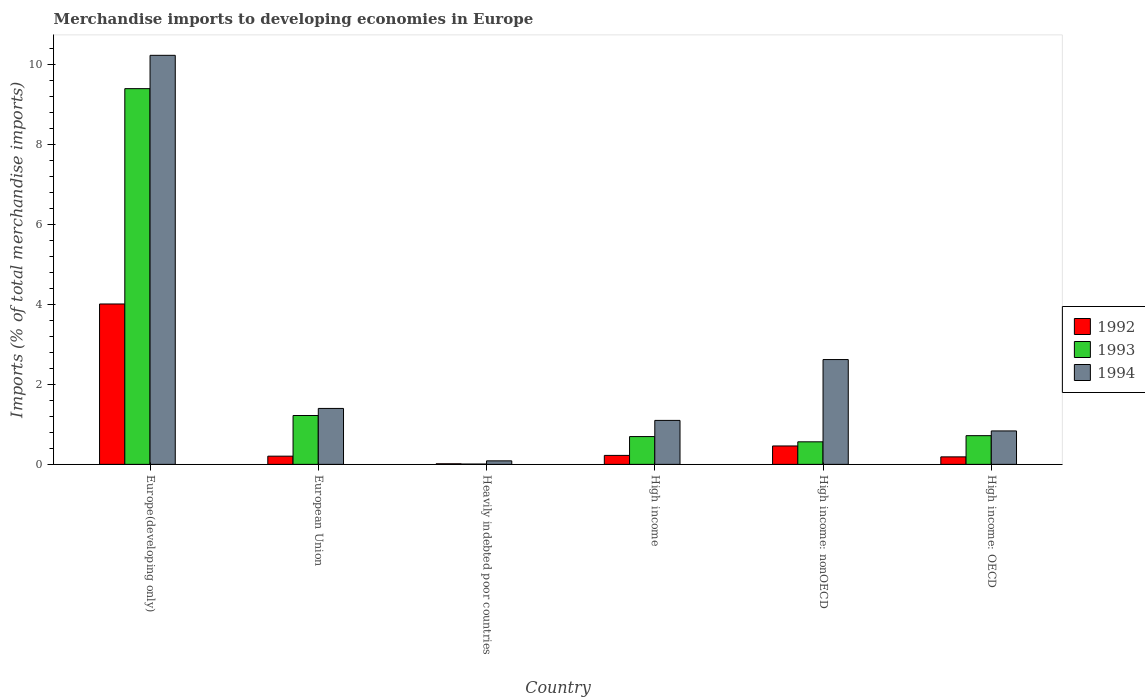Are the number of bars on each tick of the X-axis equal?
Provide a succinct answer. Yes. How many bars are there on the 5th tick from the left?
Provide a succinct answer. 3. How many bars are there on the 4th tick from the right?
Your answer should be compact. 3. What is the label of the 5th group of bars from the left?
Offer a very short reply. High income: nonOECD. In how many cases, is the number of bars for a given country not equal to the number of legend labels?
Your response must be concise. 0. What is the percentage total merchandise imports in 1993 in Europe(developing only)?
Make the answer very short. 9.39. Across all countries, what is the maximum percentage total merchandise imports in 1994?
Provide a short and direct response. 10.23. Across all countries, what is the minimum percentage total merchandise imports in 1993?
Make the answer very short. 0.01. In which country was the percentage total merchandise imports in 1993 maximum?
Provide a short and direct response. Europe(developing only). In which country was the percentage total merchandise imports in 1992 minimum?
Offer a very short reply. Heavily indebted poor countries. What is the total percentage total merchandise imports in 1994 in the graph?
Provide a short and direct response. 16.27. What is the difference between the percentage total merchandise imports in 1992 in European Union and that in High income: nonOECD?
Offer a terse response. -0.25. What is the difference between the percentage total merchandise imports in 1992 in Europe(developing only) and the percentage total merchandise imports in 1993 in Heavily indebted poor countries?
Offer a very short reply. 4. What is the average percentage total merchandise imports in 1993 per country?
Provide a short and direct response. 2.1. What is the difference between the percentage total merchandise imports of/in 1994 and percentage total merchandise imports of/in 1993 in Heavily indebted poor countries?
Provide a short and direct response. 0.08. In how many countries, is the percentage total merchandise imports in 1994 greater than 5.2 %?
Offer a very short reply. 1. What is the ratio of the percentage total merchandise imports in 1992 in Europe(developing only) to that in Heavily indebted poor countries?
Your response must be concise. 265.61. Is the difference between the percentage total merchandise imports in 1994 in European Union and High income: OECD greater than the difference between the percentage total merchandise imports in 1993 in European Union and High income: OECD?
Your answer should be very brief. Yes. What is the difference between the highest and the second highest percentage total merchandise imports in 1993?
Your answer should be compact. -8.68. What is the difference between the highest and the lowest percentage total merchandise imports in 1994?
Your answer should be very brief. 10.14. Is the sum of the percentage total merchandise imports in 1993 in Europe(developing only) and High income: OECD greater than the maximum percentage total merchandise imports in 1994 across all countries?
Offer a very short reply. No. How many bars are there?
Offer a terse response. 18. How many countries are there in the graph?
Offer a very short reply. 6. What is the difference between two consecutive major ticks on the Y-axis?
Make the answer very short. 2. Does the graph contain grids?
Give a very brief answer. No. Where does the legend appear in the graph?
Your response must be concise. Center right. How many legend labels are there?
Offer a terse response. 3. How are the legend labels stacked?
Ensure brevity in your answer.  Vertical. What is the title of the graph?
Your answer should be compact. Merchandise imports to developing economies in Europe. Does "1990" appear as one of the legend labels in the graph?
Provide a short and direct response. No. What is the label or title of the Y-axis?
Your answer should be very brief. Imports (% of total merchandise imports). What is the Imports (% of total merchandise imports) of 1992 in Europe(developing only)?
Offer a terse response. 4.01. What is the Imports (% of total merchandise imports) in 1993 in Europe(developing only)?
Keep it short and to the point. 9.39. What is the Imports (% of total merchandise imports) in 1994 in Europe(developing only)?
Give a very brief answer. 10.23. What is the Imports (% of total merchandise imports) of 1992 in European Union?
Your answer should be very brief. 0.21. What is the Imports (% of total merchandise imports) in 1993 in European Union?
Make the answer very short. 1.22. What is the Imports (% of total merchandise imports) in 1994 in European Union?
Your response must be concise. 1.4. What is the Imports (% of total merchandise imports) of 1992 in Heavily indebted poor countries?
Make the answer very short. 0.02. What is the Imports (% of total merchandise imports) of 1993 in Heavily indebted poor countries?
Offer a very short reply. 0.01. What is the Imports (% of total merchandise imports) of 1994 in Heavily indebted poor countries?
Make the answer very short. 0.09. What is the Imports (% of total merchandise imports) of 1992 in High income?
Give a very brief answer. 0.22. What is the Imports (% of total merchandise imports) in 1993 in High income?
Ensure brevity in your answer.  0.7. What is the Imports (% of total merchandise imports) of 1994 in High income?
Ensure brevity in your answer.  1.1. What is the Imports (% of total merchandise imports) in 1992 in High income: nonOECD?
Provide a succinct answer. 0.46. What is the Imports (% of total merchandise imports) of 1993 in High income: nonOECD?
Provide a succinct answer. 0.56. What is the Imports (% of total merchandise imports) in 1994 in High income: nonOECD?
Provide a succinct answer. 2.62. What is the Imports (% of total merchandise imports) in 1992 in High income: OECD?
Your response must be concise. 0.19. What is the Imports (% of total merchandise imports) in 1993 in High income: OECD?
Your answer should be compact. 0.72. What is the Imports (% of total merchandise imports) of 1994 in High income: OECD?
Offer a very short reply. 0.84. Across all countries, what is the maximum Imports (% of total merchandise imports) in 1992?
Provide a short and direct response. 4.01. Across all countries, what is the maximum Imports (% of total merchandise imports) in 1993?
Make the answer very short. 9.39. Across all countries, what is the maximum Imports (% of total merchandise imports) in 1994?
Offer a terse response. 10.23. Across all countries, what is the minimum Imports (% of total merchandise imports) of 1992?
Provide a short and direct response. 0.02. Across all countries, what is the minimum Imports (% of total merchandise imports) of 1993?
Your answer should be very brief. 0.01. Across all countries, what is the minimum Imports (% of total merchandise imports) in 1994?
Your answer should be compact. 0.09. What is the total Imports (% of total merchandise imports) of 1992 in the graph?
Your answer should be very brief. 5.1. What is the total Imports (% of total merchandise imports) in 1993 in the graph?
Offer a terse response. 12.6. What is the total Imports (% of total merchandise imports) of 1994 in the graph?
Provide a succinct answer. 16.27. What is the difference between the Imports (% of total merchandise imports) of 1992 in Europe(developing only) and that in European Union?
Your answer should be very brief. 3.8. What is the difference between the Imports (% of total merchandise imports) in 1993 in Europe(developing only) and that in European Union?
Give a very brief answer. 8.17. What is the difference between the Imports (% of total merchandise imports) of 1994 in Europe(developing only) and that in European Union?
Your answer should be compact. 8.83. What is the difference between the Imports (% of total merchandise imports) of 1992 in Europe(developing only) and that in Heavily indebted poor countries?
Provide a succinct answer. 4. What is the difference between the Imports (% of total merchandise imports) in 1993 in Europe(developing only) and that in Heavily indebted poor countries?
Give a very brief answer. 9.39. What is the difference between the Imports (% of total merchandise imports) in 1994 in Europe(developing only) and that in Heavily indebted poor countries?
Keep it short and to the point. 10.14. What is the difference between the Imports (% of total merchandise imports) in 1992 in Europe(developing only) and that in High income?
Provide a succinct answer. 3.79. What is the difference between the Imports (% of total merchandise imports) of 1993 in Europe(developing only) and that in High income?
Make the answer very short. 8.7. What is the difference between the Imports (% of total merchandise imports) of 1994 in Europe(developing only) and that in High income?
Give a very brief answer. 9.13. What is the difference between the Imports (% of total merchandise imports) of 1992 in Europe(developing only) and that in High income: nonOECD?
Make the answer very short. 3.55. What is the difference between the Imports (% of total merchandise imports) of 1993 in Europe(developing only) and that in High income: nonOECD?
Provide a short and direct response. 8.83. What is the difference between the Imports (% of total merchandise imports) in 1994 in Europe(developing only) and that in High income: nonOECD?
Your response must be concise. 7.61. What is the difference between the Imports (% of total merchandise imports) in 1992 in Europe(developing only) and that in High income: OECD?
Provide a succinct answer. 3.82. What is the difference between the Imports (% of total merchandise imports) of 1993 in Europe(developing only) and that in High income: OECD?
Offer a terse response. 8.68. What is the difference between the Imports (% of total merchandise imports) of 1994 in Europe(developing only) and that in High income: OECD?
Give a very brief answer. 9.39. What is the difference between the Imports (% of total merchandise imports) in 1992 in European Union and that in Heavily indebted poor countries?
Provide a short and direct response. 0.19. What is the difference between the Imports (% of total merchandise imports) of 1993 in European Union and that in Heavily indebted poor countries?
Your answer should be compact. 1.21. What is the difference between the Imports (% of total merchandise imports) of 1994 in European Union and that in Heavily indebted poor countries?
Provide a short and direct response. 1.31. What is the difference between the Imports (% of total merchandise imports) of 1992 in European Union and that in High income?
Keep it short and to the point. -0.02. What is the difference between the Imports (% of total merchandise imports) of 1993 in European Union and that in High income?
Ensure brevity in your answer.  0.53. What is the difference between the Imports (% of total merchandise imports) of 1994 in European Union and that in High income?
Provide a succinct answer. 0.3. What is the difference between the Imports (% of total merchandise imports) of 1992 in European Union and that in High income: nonOECD?
Offer a terse response. -0.25. What is the difference between the Imports (% of total merchandise imports) in 1993 in European Union and that in High income: nonOECD?
Offer a terse response. 0.66. What is the difference between the Imports (% of total merchandise imports) of 1994 in European Union and that in High income: nonOECD?
Offer a very short reply. -1.22. What is the difference between the Imports (% of total merchandise imports) of 1992 in European Union and that in High income: OECD?
Provide a short and direct response. 0.02. What is the difference between the Imports (% of total merchandise imports) of 1993 in European Union and that in High income: OECD?
Offer a very short reply. 0.5. What is the difference between the Imports (% of total merchandise imports) of 1994 in European Union and that in High income: OECD?
Your response must be concise. 0.56. What is the difference between the Imports (% of total merchandise imports) of 1992 in Heavily indebted poor countries and that in High income?
Provide a short and direct response. -0.21. What is the difference between the Imports (% of total merchandise imports) in 1993 in Heavily indebted poor countries and that in High income?
Ensure brevity in your answer.  -0.69. What is the difference between the Imports (% of total merchandise imports) in 1994 in Heavily indebted poor countries and that in High income?
Provide a succinct answer. -1.01. What is the difference between the Imports (% of total merchandise imports) of 1992 in Heavily indebted poor countries and that in High income: nonOECD?
Ensure brevity in your answer.  -0.45. What is the difference between the Imports (% of total merchandise imports) in 1993 in Heavily indebted poor countries and that in High income: nonOECD?
Your answer should be very brief. -0.56. What is the difference between the Imports (% of total merchandise imports) of 1994 in Heavily indebted poor countries and that in High income: nonOECD?
Make the answer very short. -2.53. What is the difference between the Imports (% of total merchandise imports) of 1992 in Heavily indebted poor countries and that in High income: OECD?
Your answer should be compact. -0.17. What is the difference between the Imports (% of total merchandise imports) of 1993 in Heavily indebted poor countries and that in High income: OECD?
Your response must be concise. -0.71. What is the difference between the Imports (% of total merchandise imports) of 1994 in Heavily indebted poor countries and that in High income: OECD?
Make the answer very short. -0.75. What is the difference between the Imports (% of total merchandise imports) of 1992 in High income and that in High income: nonOECD?
Provide a succinct answer. -0.24. What is the difference between the Imports (% of total merchandise imports) in 1993 in High income and that in High income: nonOECD?
Your response must be concise. 0.13. What is the difference between the Imports (% of total merchandise imports) in 1994 in High income and that in High income: nonOECD?
Your answer should be very brief. -1.52. What is the difference between the Imports (% of total merchandise imports) in 1992 in High income and that in High income: OECD?
Your response must be concise. 0.04. What is the difference between the Imports (% of total merchandise imports) in 1993 in High income and that in High income: OECD?
Provide a succinct answer. -0.02. What is the difference between the Imports (% of total merchandise imports) in 1994 in High income and that in High income: OECD?
Provide a short and direct response. 0.26. What is the difference between the Imports (% of total merchandise imports) of 1992 in High income: nonOECD and that in High income: OECD?
Your response must be concise. 0.27. What is the difference between the Imports (% of total merchandise imports) in 1993 in High income: nonOECD and that in High income: OECD?
Make the answer very short. -0.15. What is the difference between the Imports (% of total merchandise imports) of 1994 in High income: nonOECD and that in High income: OECD?
Make the answer very short. 1.78. What is the difference between the Imports (% of total merchandise imports) of 1992 in Europe(developing only) and the Imports (% of total merchandise imports) of 1993 in European Union?
Your answer should be compact. 2.79. What is the difference between the Imports (% of total merchandise imports) in 1992 in Europe(developing only) and the Imports (% of total merchandise imports) in 1994 in European Union?
Offer a very short reply. 2.61. What is the difference between the Imports (% of total merchandise imports) in 1993 in Europe(developing only) and the Imports (% of total merchandise imports) in 1994 in European Union?
Offer a terse response. 8. What is the difference between the Imports (% of total merchandise imports) of 1992 in Europe(developing only) and the Imports (% of total merchandise imports) of 1993 in Heavily indebted poor countries?
Provide a succinct answer. 4. What is the difference between the Imports (% of total merchandise imports) of 1992 in Europe(developing only) and the Imports (% of total merchandise imports) of 1994 in Heavily indebted poor countries?
Make the answer very short. 3.92. What is the difference between the Imports (% of total merchandise imports) in 1993 in Europe(developing only) and the Imports (% of total merchandise imports) in 1994 in Heavily indebted poor countries?
Keep it short and to the point. 9.31. What is the difference between the Imports (% of total merchandise imports) in 1992 in Europe(developing only) and the Imports (% of total merchandise imports) in 1993 in High income?
Keep it short and to the point. 3.32. What is the difference between the Imports (% of total merchandise imports) of 1992 in Europe(developing only) and the Imports (% of total merchandise imports) of 1994 in High income?
Provide a succinct answer. 2.91. What is the difference between the Imports (% of total merchandise imports) of 1993 in Europe(developing only) and the Imports (% of total merchandise imports) of 1994 in High income?
Your answer should be compact. 8.29. What is the difference between the Imports (% of total merchandise imports) in 1992 in Europe(developing only) and the Imports (% of total merchandise imports) in 1993 in High income: nonOECD?
Ensure brevity in your answer.  3.45. What is the difference between the Imports (% of total merchandise imports) of 1992 in Europe(developing only) and the Imports (% of total merchandise imports) of 1994 in High income: nonOECD?
Your answer should be very brief. 1.39. What is the difference between the Imports (% of total merchandise imports) of 1993 in Europe(developing only) and the Imports (% of total merchandise imports) of 1994 in High income: nonOECD?
Offer a very short reply. 6.77. What is the difference between the Imports (% of total merchandise imports) in 1992 in Europe(developing only) and the Imports (% of total merchandise imports) in 1993 in High income: OECD?
Offer a very short reply. 3.29. What is the difference between the Imports (% of total merchandise imports) in 1992 in Europe(developing only) and the Imports (% of total merchandise imports) in 1994 in High income: OECD?
Provide a succinct answer. 3.17. What is the difference between the Imports (% of total merchandise imports) of 1993 in Europe(developing only) and the Imports (% of total merchandise imports) of 1994 in High income: OECD?
Give a very brief answer. 8.56. What is the difference between the Imports (% of total merchandise imports) of 1992 in European Union and the Imports (% of total merchandise imports) of 1993 in Heavily indebted poor countries?
Provide a short and direct response. 0.2. What is the difference between the Imports (% of total merchandise imports) of 1992 in European Union and the Imports (% of total merchandise imports) of 1994 in Heavily indebted poor countries?
Ensure brevity in your answer.  0.12. What is the difference between the Imports (% of total merchandise imports) of 1993 in European Union and the Imports (% of total merchandise imports) of 1994 in Heavily indebted poor countries?
Your answer should be very brief. 1.13. What is the difference between the Imports (% of total merchandise imports) in 1992 in European Union and the Imports (% of total merchandise imports) in 1993 in High income?
Offer a very short reply. -0.49. What is the difference between the Imports (% of total merchandise imports) of 1992 in European Union and the Imports (% of total merchandise imports) of 1994 in High income?
Make the answer very short. -0.89. What is the difference between the Imports (% of total merchandise imports) in 1993 in European Union and the Imports (% of total merchandise imports) in 1994 in High income?
Your response must be concise. 0.12. What is the difference between the Imports (% of total merchandise imports) of 1992 in European Union and the Imports (% of total merchandise imports) of 1993 in High income: nonOECD?
Offer a very short reply. -0.36. What is the difference between the Imports (% of total merchandise imports) of 1992 in European Union and the Imports (% of total merchandise imports) of 1994 in High income: nonOECD?
Offer a terse response. -2.42. What is the difference between the Imports (% of total merchandise imports) of 1993 in European Union and the Imports (% of total merchandise imports) of 1994 in High income: nonOECD?
Keep it short and to the point. -1.4. What is the difference between the Imports (% of total merchandise imports) in 1992 in European Union and the Imports (% of total merchandise imports) in 1993 in High income: OECD?
Give a very brief answer. -0.51. What is the difference between the Imports (% of total merchandise imports) in 1992 in European Union and the Imports (% of total merchandise imports) in 1994 in High income: OECD?
Your answer should be very brief. -0.63. What is the difference between the Imports (% of total merchandise imports) of 1993 in European Union and the Imports (% of total merchandise imports) of 1994 in High income: OECD?
Give a very brief answer. 0.39. What is the difference between the Imports (% of total merchandise imports) in 1992 in Heavily indebted poor countries and the Imports (% of total merchandise imports) in 1993 in High income?
Your answer should be compact. -0.68. What is the difference between the Imports (% of total merchandise imports) of 1992 in Heavily indebted poor countries and the Imports (% of total merchandise imports) of 1994 in High income?
Your answer should be very brief. -1.08. What is the difference between the Imports (% of total merchandise imports) of 1993 in Heavily indebted poor countries and the Imports (% of total merchandise imports) of 1994 in High income?
Provide a short and direct response. -1.09. What is the difference between the Imports (% of total merchandise imports) in 1992 in Heavily indebted poor countries and the Imports (% of total merchandise imports) in 1993 in High income: nonOECD?
Offer a terse response. -0.55. What is the difference between the Imports (% of total merchandise imports) in 1992 in Heavily indebted poor countries and the Imports (% of total merchandise imports) in 1994 in High income: nonOECD?
Offer a very short reply. -2.61. What is the difference between the Imports (% of total merchandise imports) of 1993 in Heavily indebted poor countries and the Imports (% of total merchandise imports) of 1994 in High income: nonOECD?
Your response must be concise. -2.61. What is the difference between the Imports (% of total merchandise imports) of 1992 in Heavily indebted poor countries and the Imports (% of total merchandise imports) of 1993 in High income: OECD?
Your answer should be compact. -0.7. What is the difference between the Imports (% of total merchandise imports) in 1992 in Heavily indebted poor countries and the Imports (% of total merchandise imports) in 1994 in High income: OECD?
Offer a terse response. -0.82. What is the difference between the Imports (% of total merchandise imports) of 1993 in Heavily indebted poor countries and the Imports (% of total merchandise imports) of 1994 in High income: OECD?
Make the answer very short. -0.83. What is the difference between the Imports (% of total merchandise imports) in 1992 in High income and the Imports (% of total merchandise imports) in 1993 in High income: nonOECD?
Keep it short and to the point. -0.34. What is the difference between the Imports (% of total merchandise imports) in 1992 in High income and the Imports (% of total merchandise imports) in 1994 in High income: nonOECD?
Your response must be concise. -2.4. What is the difference between the Imports (% of total merchandise imports) of 1993 in High income and the Imports (% of total merchandise imports) of 1994 in High income: nonOECD?
Provide a short and direct response. -1.93. What is the difference between the Imports (% of total merchandise imports) in 1992 in High income and the Imports (% of total merchandise imports) in 1993 in High income: OECD?
Offer a terse response. -0.49. What is the difference between the Imports (% of total merchandise imports) of 1992 in High income and the Imports (% of total merchandise imports) of 1994 in High income: OECD?
Provide a short and direct response. -0.61. What is the difference between the Imports (% of total merchandise imports) in 1993 in High income and the Imports (% of total merchandise imports) in 1994 in High income: OECD?
Your response must be concise. -0.14. What is the difference between the Imports (% of total merchandise imports) in 1992 in High income: nonOECD and the Imports (% of total merchandise imports) in 1993 in High income: OECD?
Keep it short and to the point. -0.26. What is the difference between the Imports (% of total merchandise imports) in 1992 in High income: nonOECD and the Imports (% of total merchandise imports) in 1994 in High income: OECD?
Your response must be concise. -0.38. What is the difference between the Imports (% of total merchandise imports) of 1993 in High income: nonOECD and the Imports (% of total merchandise imports) of 1994 in High income: OECD?
Ensure brevity in your answer.  -0.27. What is the average Imports (% of total merchandise imports) of 1992 per country?
Your response must be concise. 0.85. What is the average Imports (% of total merchandise imports) in 1993 per country?
Your response must be concise. 2.1. What is the average Imports (% of total merchandise imports) of 1994 per country?
Give a very brief answer. 2.71. What is the difference between the Imports (% of total merchandise imports) of 1992 and Imports (% of total merchandise imports) of 1993 in Europe(developing only)?
Offer a very short reply. -5.38. What is the difference between the Imports (% of total merchandise imports) of 1992 and Imports (% of total merchandise imports) of 1994 in Europe(developing only)?
Ensure brevity in your answer.  -6.22. What is the difference between the Imports (% of total merchandise imports) in 1993 and Imports (% of total merchandise imports) in 1994 in Europe(developing only)?
Offer a terse response. -0.83. What is the difference between the Imports (% of total merchandise imports) in 1992 and Imports (% of total merchandise imports) in 1993 in European Union?
Offer a very short reply. -1.02. What is the difference between the Imports (% of total merchandise imports) in 1992 and Imports (% of total merchandise imports) in 1994 in European Union?
Your answer should be very brief. -1.19. What is the difference between the Imports (% of total merchandise imports) of 1993 and Imports (% of total merchandise imports) of 1994 in European Union?
Provide a succinct answer. -0.18. What is the difference between the Imports (% of total merchandise imports) in 1992 and Imports (% of total merchandise imports) in 1993 in Heavily indebted poor countries?
Provide a short and direct response. 0.01. What is the difference between the Imports (% of total merchandise imports) in 1992 and Imports (% of total merchandise imports) in 1994 in Heavily indebted poor countries?
Make the answer very short. -0.07. What is the difference between the Imports (% of total merchandise imports) of 1993 and Imports (% of total merchandise imports) of 1994 in Heavily indebted poor countries?
Offer a terse response. -0.08. What is the difference between the Imports (% of total merchandise imports) in 1992 and Imports (% of total merchandise imports) in 1993 in High income?
Your answer should be compact. -0.47. What is the difference between the Imports (% of total merchandise imports) of 1992 and Imports (% of total merchandise imports) of 1994 in High income?
Keep it short and to the point. -0.88. What is the difference between the Imports (% of total merchandise imports) of 1993 and Imports (% of total merchandise imports) of 1994 in High income?
Offer a very short reply. -0.4. What is the difference between the Imports (% of total merchandise imports) in 1992 and Imports (% of total merchandise imports) in 1993 in High income: nonOECD?
Your answer should be compact. -0.1. What is the difference between the Imports (% of total merchandise imports) in 1992 and Imports (% of total merchandise imports) in 1994 in High income: nonOECD?
Give a very brief answer. -2.16. What is the difference between the Imports (% of total merchandise imports) of 1993 and Imports (% of total merchandise imports) of 1994 in High income: nonOECD?
Offer a terse response. -2.06. What is the difference between the Imports (% of total merchandise imports) in 1992 and Imports (% of total merchandise imports) in 1993 in High income: OECD?
Your answer should be very brief. -0.53. What is the difference between the Imports (% of total merchandise imports) of 1992 and Imports (% of total merchandise imports) of 1994 in High income: OECD?
Your answer should be compact. -0.65. What is the difference between the Imports (% of total merchandise imports) of 1993 and Imports (% of total merchandise imports) of 1994 in High income: OECD?
Your answer should be very brief. -0.12. What is the ratio of the Imports (% of total merchandise imports) of 1992 in Europe(developing only) to that in European Union?
Your answer should be compact. 19.52. What is the ratio of the Imports (% of total merchandise imports) in 1993 in Europe(developing only) to that in European Union?
Your answer should be compact. 7.69. What is the ratio of the Imports (% of total merchandise imports) in 1994 in Europe(developing only) to that in European Union?
Offer a very short reply. 7.31. What is the ratio of the Imports (% of total merchandise imports) of 1992 in Europe(developing only) to that in Heavily indebted poor countries?
Keep it short and to the point. 265.61. What is the ratio of the Imports (% of total merchandise imports) of 1993 in Europe(developing only) to that in Heavily indebted poor countries?
Your response must be concise. 1135.41. What is the ratio of the Imports (% of total merchandise imports) of 1994 in Europe(developing only) to that in Heavily indebted poor countries?
Your answer should be compact. 116.26. What is the ratio of the Imports (% of total merchandise imports) in 1992 in Europe(developing only) to that in High income?
Offer a very short reply. 17.88. What is the ratio of the Imports (% of total merchandise imports) in 1993 in Europe(developing only) to that in High income?
Provide a short and direct response. 13.51. What is the ratio of the Imports (% of total merchandise imports) in 1994 in Europe(developing only) to that in High income?
Ensure brevity in your answer.  9.3. What is the ratio of the Imports (% of total merchandise imports) in 1992 in Europe(developing only) to that in High income: nonOECD?
Your answer should be very brief. 8.71. What is the ratio of the Imports (% of total merchandise imports) in 1993 in Europe(developing only) to that in High income: nonOECD?
Keep it short and to the point. 16.66. What is the ratio of the Imports (% of total merchandise imports) in 1994 in Europe(developing only) to that in High income: nonOECD?
Give a very brief answer. 3.9. What is the ratio of the Imports (% of total merchandise imports) in 1992 in Europe(developing only) to that in High income: OECD?
Your answer should be very brief. 21.36. What is the ratio of the Imports (% of total merchandise imports) of 1993 in Europe(developing only) to that in High income: OECD?
Give a very brief answer. 13.08. What is the ratio of the Imports (% of total merchandise imports) in 1994 in Europe(developing only) to that in High income: OECD?
Offer a very short reply. 12.23. What is the ratio of the Imports (% of total merchandise imports) of 1992 in European Union to that in Heavily indebted poor countries?
Your answer should be compact. 13.61. What is the ratio of the Imports (% of total merchandise imports) in 1993 in European Union to that in Heavily indebted poor countries?
Your answer should be very brief. 147.67. What is the ratio of the Imports (% of total merchandise imports) of 1994 in European Union to that in Heavily indebted poor countries?
Provide a succinct answer. 15.9. What is the ratio of the Imports (% of total merchandise imports) of 1992 in European Union to that in High income?
Your response must be concise. 0.92. What is the ratio of the Imports (% of total merchandise imports) of 1993 in European Union to that in High income?
Ensure brevity in your answer.  1.76. What is the ratio of the Imports (% of total merchandise imports) of 1994 in European Union to that in High income?
Offer a very short reply. 1.27. What is the ratio of the Imports (% of total merchandise imports) of 1992 in European Union to that in High income: nonOECD?
Give a very brief answer. 0.45. What is the ratio of the Imports (% of total merchandise imports) of 1993 in European Union to that in High income: nonOECD?
Your answer should be compact. 2.17. What is the ratio of the Imports (% of total merchandise imports) of 1994 in European Union to that in High income: nonOECD?
Keep it short and to the point. 0.53. What is the ratio of the Imports (% of total merchandise imports) of 1992 in European Union to that in High income: OECD?
Make the answer very short. 1.09. What is the ratio of the Imports (% of total merchandise imports) in 1993 in European Union to that in High income: OECD?
Your answer should be very brief. 1.7. What is the ratio of the Imports (% of total merchandise imports) of 1994 in European Union to that in High income: OECD?
Make the answer very short. 1.67. What is the ratio of the Imports (% of total merchandise imports) in 1992 in Heavily indebted poor countries to that in High income?
Offer a very short reply. 0.07. What is the ratio of the Imports (% of total merchandise imports) in 1993 in Heavily indebted poor countries to that in High income?
Your response must be concise. 0.01. What is the ratio of the Imports (% of total merchandise imports) of 1992 in Heavily indebted poor countries to that in High income: nonOECD?
Keep it short and to the point. 0.03. What is the ratio of the Imports (% of total merchandise imports) in 1993 in Heavily indebted poor countries to that in High income: nonOECD?
Your answer should be very brief. 0.01. What is the ratio of the Imports (% of total merchandise imports) of 1994 in Heavily indebted poor countries to that in High income: nonOECD?
Make the answer very short. 0.03. What is the ratio of the Imports (% of total merchandise imports) in 1992 in Heavily indebted poor countries to that in High income: OECD?
Your answer should be very brief. 0.08. What is the ratio of the Imports (% of total merchandise imports) in 1993 in Heavily indebted poor countries to that in High income: OECD?
Ensure brevity in your answer.  0.01. What is the ratio of the Imports (% of total merchandise imports) of 1994 in Heavily indebted poor countries to that in High income: OECD?
Keep it short and to the point. 0.11. What is the ratio of the Imports (% of total merchandise imports) of 1992 in High income to that in High income: nonOECD?
Give a very brief answer. 0.49. What is the ratio of the Imports (% of total merchandise imports) in 1993 in High income to that in High income: nonOECD?
Your answer should be very brief. 1.23. What is the ratio of the Imports (% of total merchandise imports) of 1994 in High income to that in High income: nonOECD?
Offer a terse response. 0.42. What is the ratio of the Imports (% of total merchandise imports) of 1992 in High income to that in High income: OECD?
Make the answer very short. 1.19. What is the ratio of the Imports (% of total merchandise imports) of 1993 in High income to that in High income: OECD?
Offer a terse response. 0.97. What is the ratio of the Imports (% of total merchandise imports) of 1994 in High income to that in High income: OECD?
Provide a short and direct response. 1.31. What is the ratio of the Imports (% of total merchandise imports) in 1992 in High income: nonOECD to that in High income: OECD?
Offer a very short reply. 2.45. What is the ratio of the Imports (% of total merchandise imports) of 1993 in High income: nonOECD to that in High income: OECD?
Offer a terse response. 0.79. What is the ratio of the Imports (% of total merchandise imports) of 1994 in High income: nonOECD to that in High income: OECD?
Ensure brevity in your answer.  3.13. What is the difference between the highest and the second highest Imports (% of total merchandise imports) in 1992?
Your answer should be compact. 3.55. What is the difference between the highest and the second highest Imports (% of total merchandise imports) of 1993?
Your response must be concise. 8.17. What is the difference between the highest and the second highest Imports (% of total merchandise imports) in 1994?
Provide a short and direct response. 7.61. What is the difference between the highest and the lowest Imports (% of total merchandise imports) in 1992?
Your answer should be very brief. 4. What is the difference between the highest and the lowest Imports (% of total merchandise imports) in 1993?
Your answer should be compact. 9.39. What is the difference between the highest and the lowest Imports (% of total merchandise imports) in 1994?
Provide a short and direct response. 10.14. 